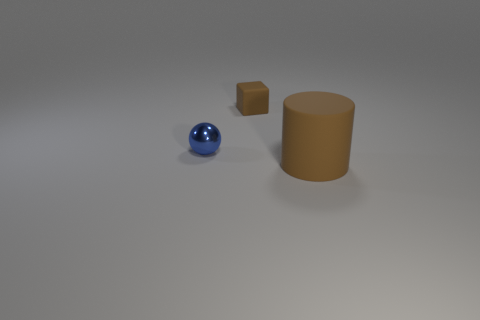Is there any other thing that has the same material as the tiny blue object?
Provide a succinct answer. No. There is a brown object in front of the shiny object; is its size the same as the tiny cube?
Give a very brief answer. No. Are the brown object that is behind the large thing and the brown object in front of the small blue sphere made of the same material?
Give a very brief answer. Yes. Is there a matte block that has the same size as the metal ball?
Offer a very short reply. Yes. There is a matte thing that is in front of the object to the left of the rubber thing that is behind the large brown cylinder; what is its shape?
Keep it short and to the point. Cylinder. Are there more big brown matte things that are to the right of the matte block than tiny cyan cylinders?
Provide a short and direct response. Yes. Do the large cylinder and the brown object that is behind the large matte cylinder have the same material?
Your answer should be compact. Yes. The shiny object is what color?
Give a very brief answer. Blue. There is a brown matte thing that is to the right of the rubber thing on the left side of the large brown rubber object; how many tiny things are behind it?
Offer a terse response. 2. There is a small brown matte cube; are there any objects in front of it?
Give a very brief answer. Yes. 